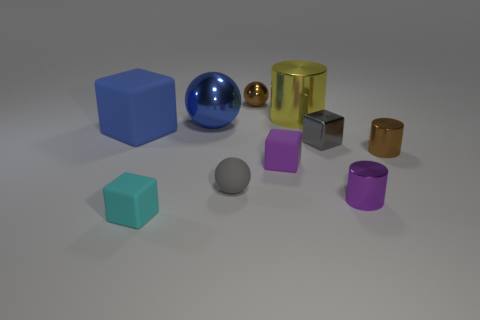Subtract 1 balls. How many balls are left? 2 Subtract all blue blocks. Subtract all brown cylinders. How many blocks are left? 3 Subtract all balls. How many objects are left? 7 Add 6 brown spheres. How many brown spheres exist? 7 Subtract 1 purple blocks. How many objects are left? 9 Subtract all cyan matte spheres. Subtract all blue cubes. How many objects are left? 9 Add 8 yellow objects. How many yellow objects are left? 9 